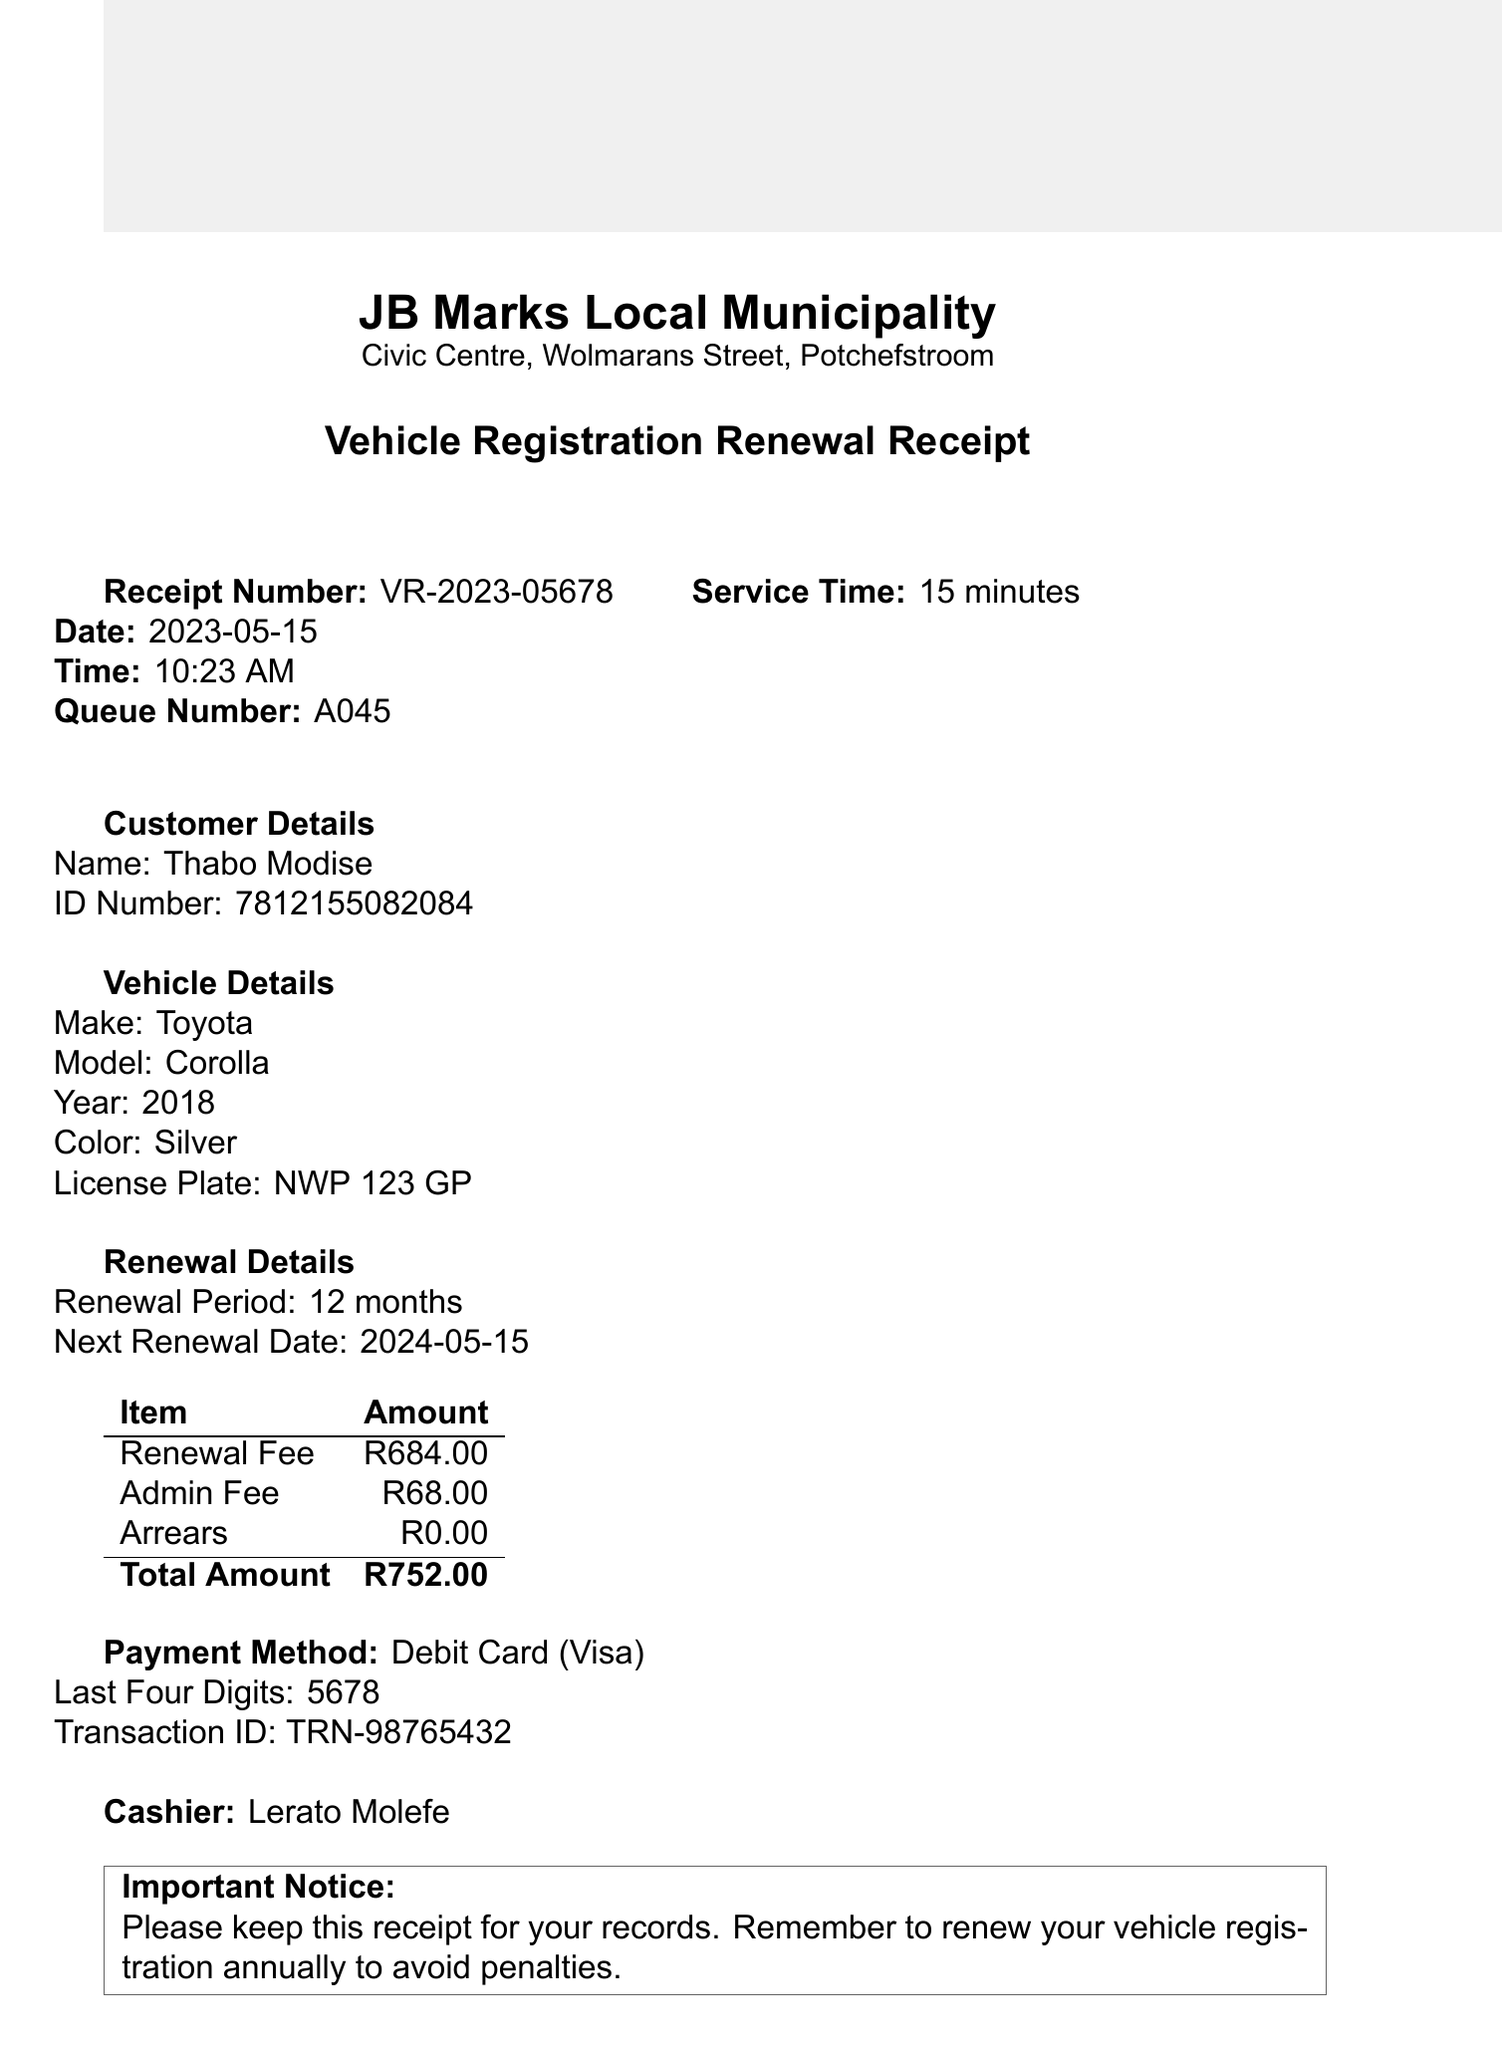What is the receipt number? The receipt number is a unique identifier for the transaction and is listed in the document as VR-2023-05678.
Answer: VR-2023-05678 What is the total amount? The total amount is the sum of the renewal fee and any additional fees incurred, which is stated as R752.00 in the document.
Answer: R752.00 Who is the cashier? The name of the cashier who processed the transaction is provided in the document as Lerato Molefe.
Answer: Lerato Molefe When is the next renewal date? The next renewal date is provided in the document and indicates when the vehicle registration will need to be renewed again, which is 2024-05-15.
Answer: 2024-05-15 What vehicle model is listed? The vehicle model is an important detail concerning the customer's vehicle and is categorized in the document as Corolla.
Answer: Corolla How much is the admin fee? The admin fee is listed as an additional fee associated with the renewal process in the document, which is R68.00.
Answer: R68.00 What payment method was used? The payment method provides insight into how the transaction was completed; in this case, it is indicated as Debit Card in the receipt.
Answer: Debit Card What is the customer's name? The document specifies the name of the customer who renewed the vehicle registration as Thabo Modise.
Answer: Thabo Modise What is the operating hours? The operating hours indicate when the municipal office is open for services, and it is stated in the document as Monday to Friday: 8:00 AM - 4:00 PM.
Answer: Monday to Friday: 8:00 AM - 4:00 PM 